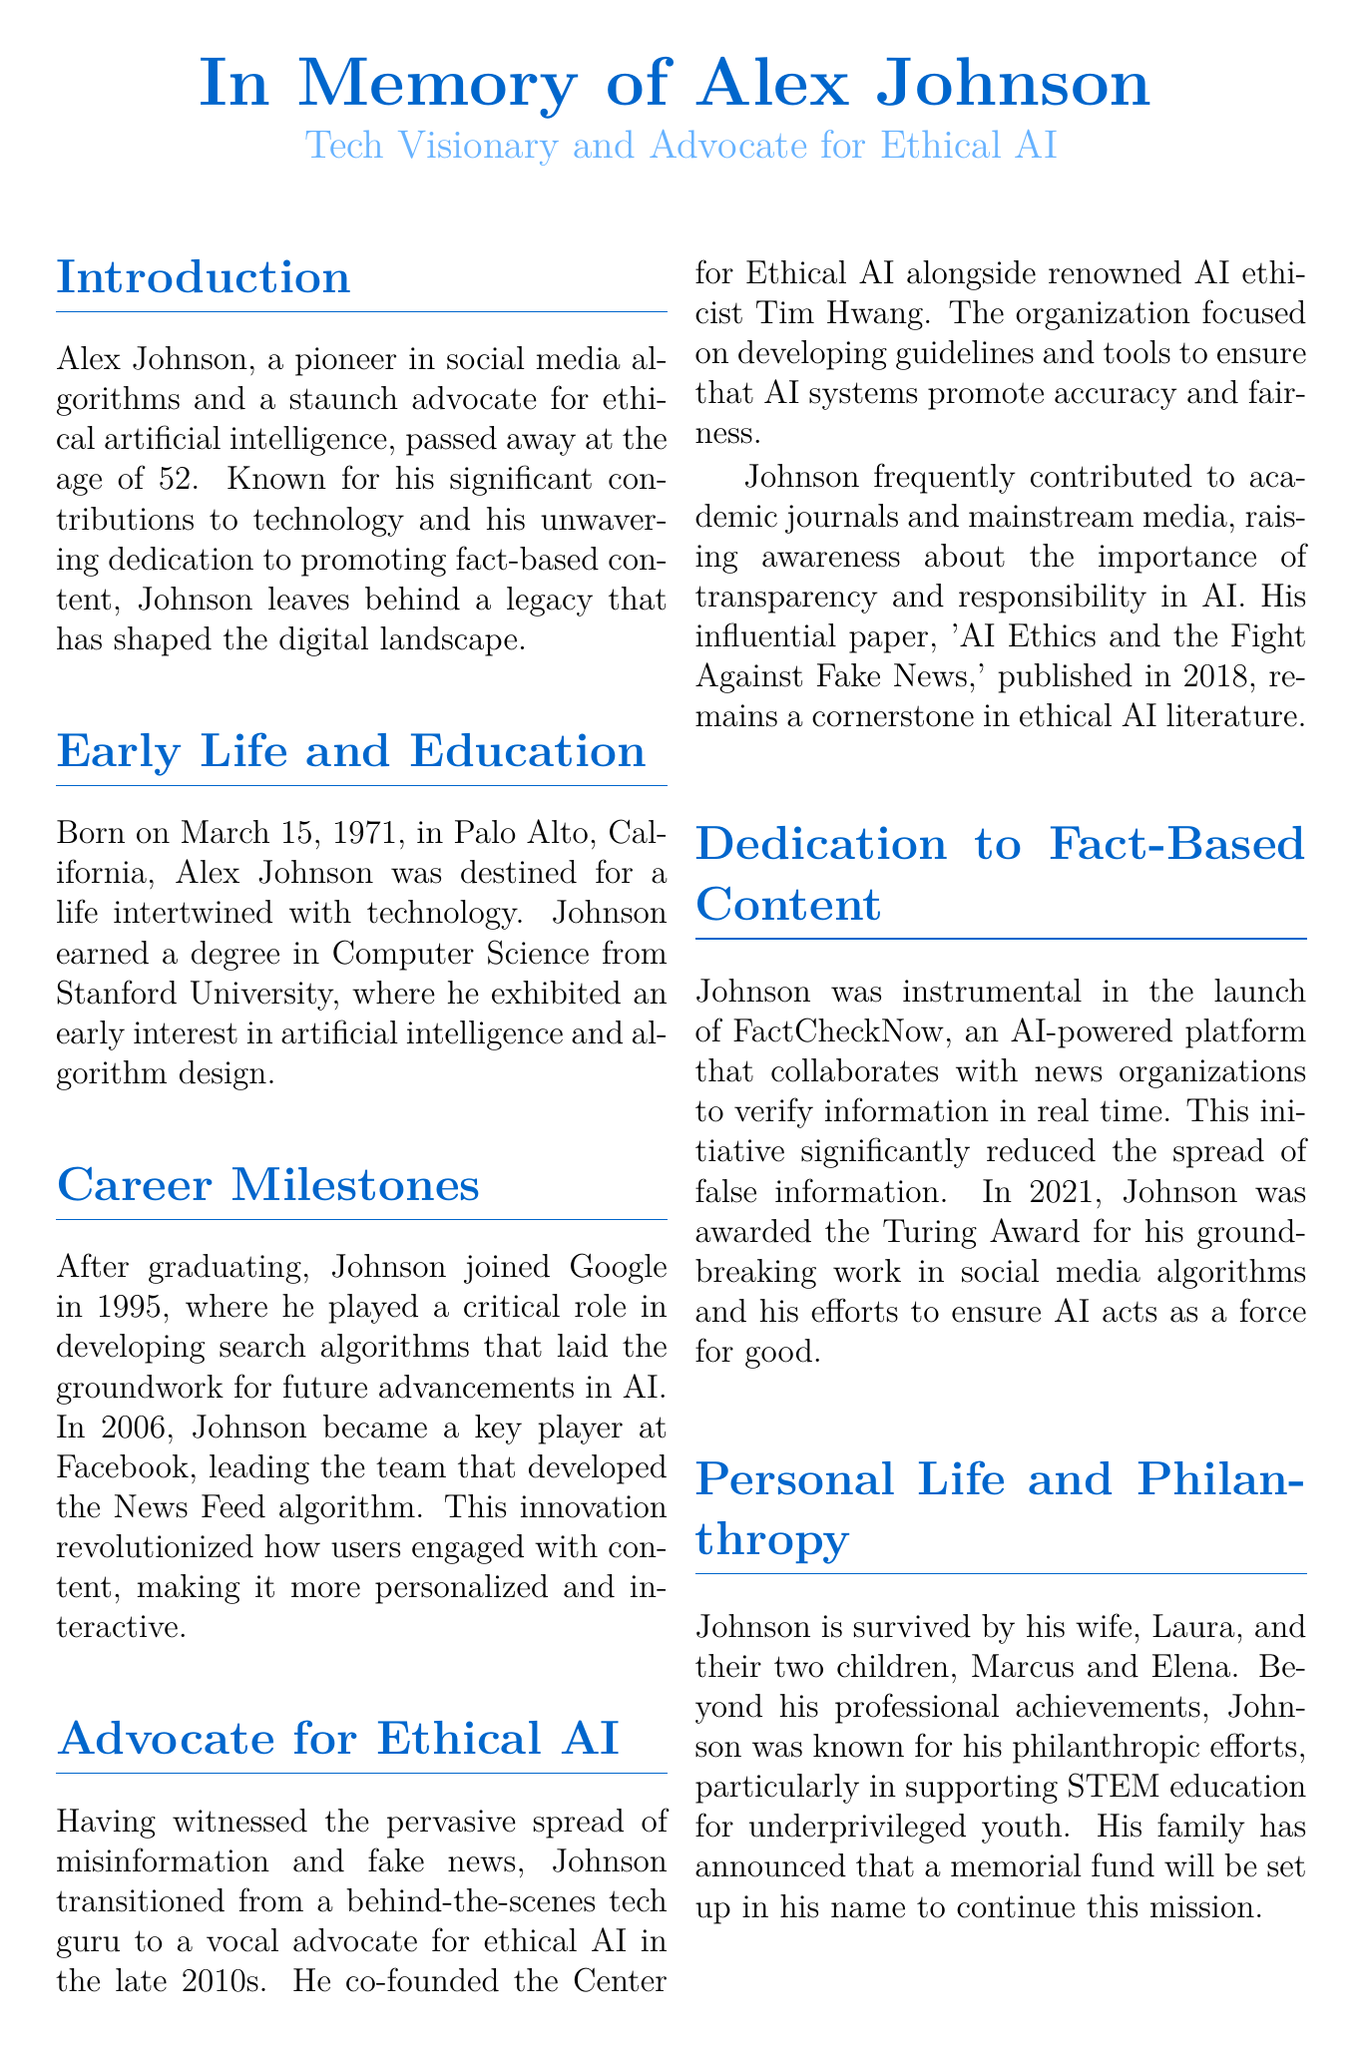What was Alex Johnson's age at the time of death? Alex Johnson passed away at the age of 52, which is explicitly stated in the introduction.
Answer: 52 When was Alex Johnson born? The document states his birth date as March 15, 1971, in the early life section.
Answer: March 15, 1971 Which major tech company did Johnson join in 1995? The text mentions that Johnson joined Google in 1995 after graduating.
Answer: Google What award did Johnson receive in 2021? The document specifies that Johnson was awarded the Turing Award in 2021 for his contributions.
Answer: Turing Award What organization did Johnson co-found? According to the document, he co-founded the Center for Ethical AI to address issues in AI ethics.
Answer: Center for Ethical AI How did Johnson contribute to fighting misinformation? The document describes his role in launching FactCheckNow, an AI-powered platform for verification.
Answer: FactCheckNow What was the title of Johnson's influential paper published in 2018? The document states that the paper titled 'AI Ethics and the Fight Against Fake News' is a significant part of his advocacy work.
Answer: AI Ethics and the Fight Against Fake News What was a key focus of Johnson's philanthropic efforts? The text highlights that Johnson supported STEM education for underprivileged youth as part of his philanthropic work.
Answer: STEM education Which algorithm did Johnson lead the development of at Facebook? The document notes that he led the team that developed the News Feed algorithm at Facebook.
Answer: News Feed algorithm 